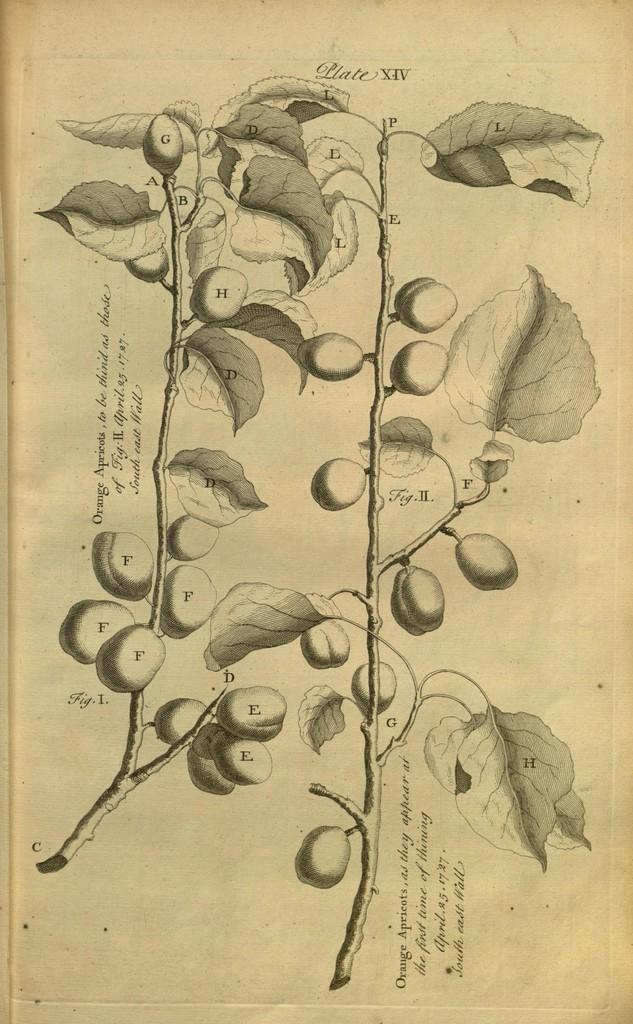What is the main subject of the paper in the image? The paper contains a drawing or image of a plant with fruits. What else is present on the paper besides the image? There is text written on the paper. What is the color scheme of the image? The image is black and white. Can you see a crown on the plant in the image? There is no crown present on the plant in the image; it only shows a plant with fruits. What type of lettuce is depicted in the image? There is no lettuce present in the image; it features a plant with fruits. 